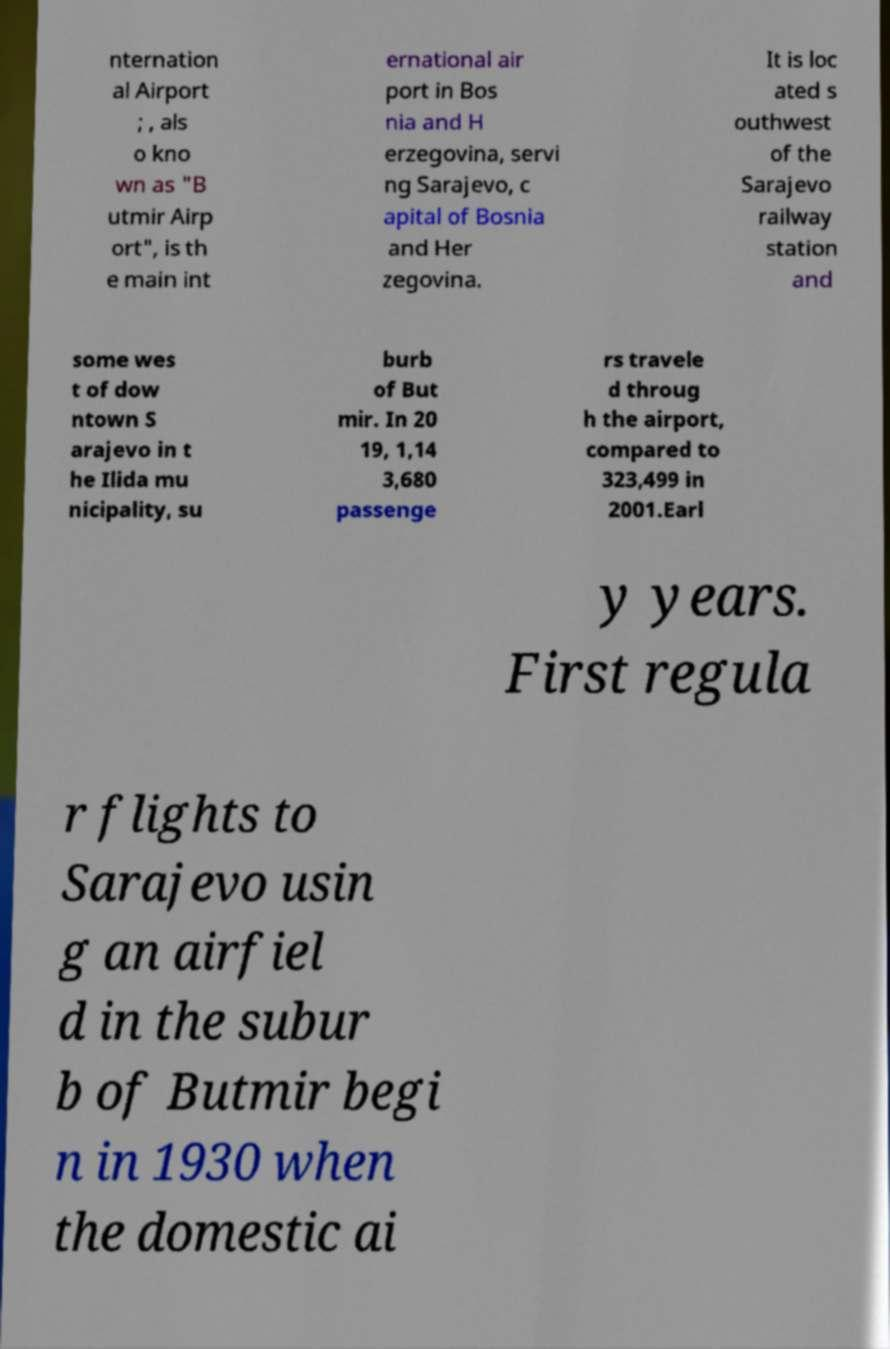Could you extract and type out the text from this image? nternation al Airport ; , als o kno wn as "B utmir Airp ort", is th e main int ernational air port in Bos nia and H erzegovina, servi ng Sarajevo, c apital of Bosnia and Her zegovina. It is loc ated s outhwest of the Sarajevo railway station and some wes t of dow ntown S arajevo in t he Ilida mu nicipality, su burb of But mir. In 20 19, 1,14 3,680 passenge rs travele d throug h the airport, compared to 323,499 in 2001.Earl y years. First regula r flights to Sarajevo usin g an airfiel d in the subur b of Butmir begi n in 1930 when the domestic ai 